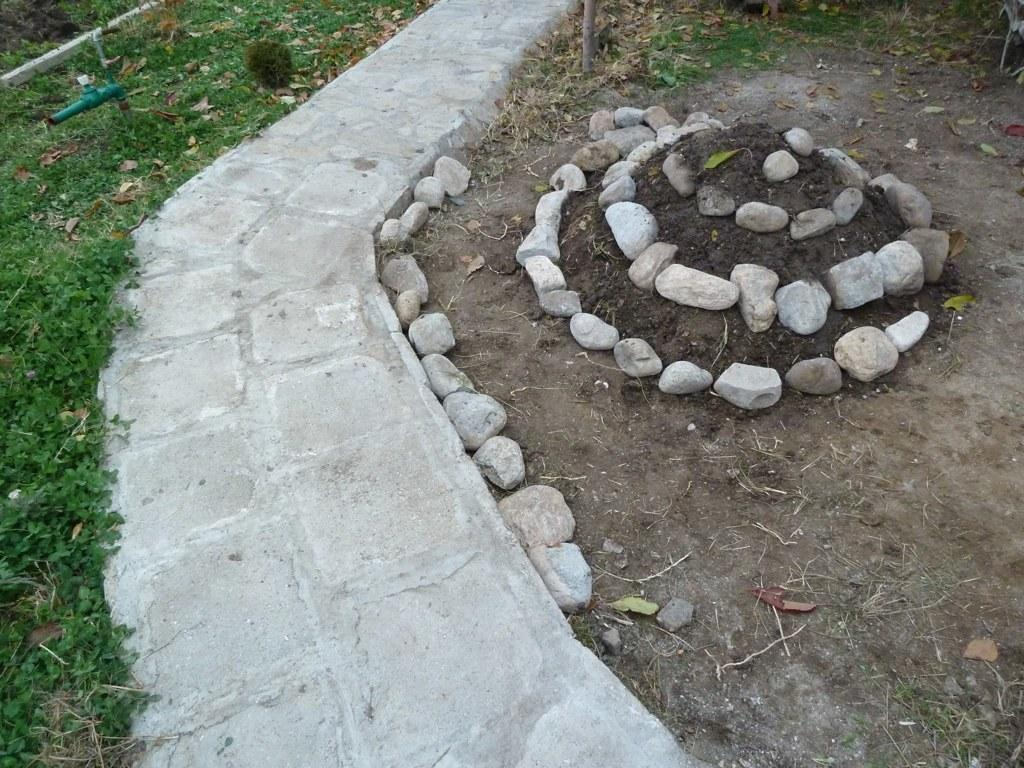What type of natural elements can be seen in the image? There are stones and grass in the image. Can you describe the texture of the stones? The texture of the stones cannot be determined from the image alone. What type of vegetation is present in the image? Grass is present in the image. What type of juice is being poured from the window in the image? There is no window or juice present in the image. How is the string being used in the image? There is no string present in the image. 